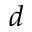<formula> <loc_0><loc_0><loc_500><loc_500>d</formula> 